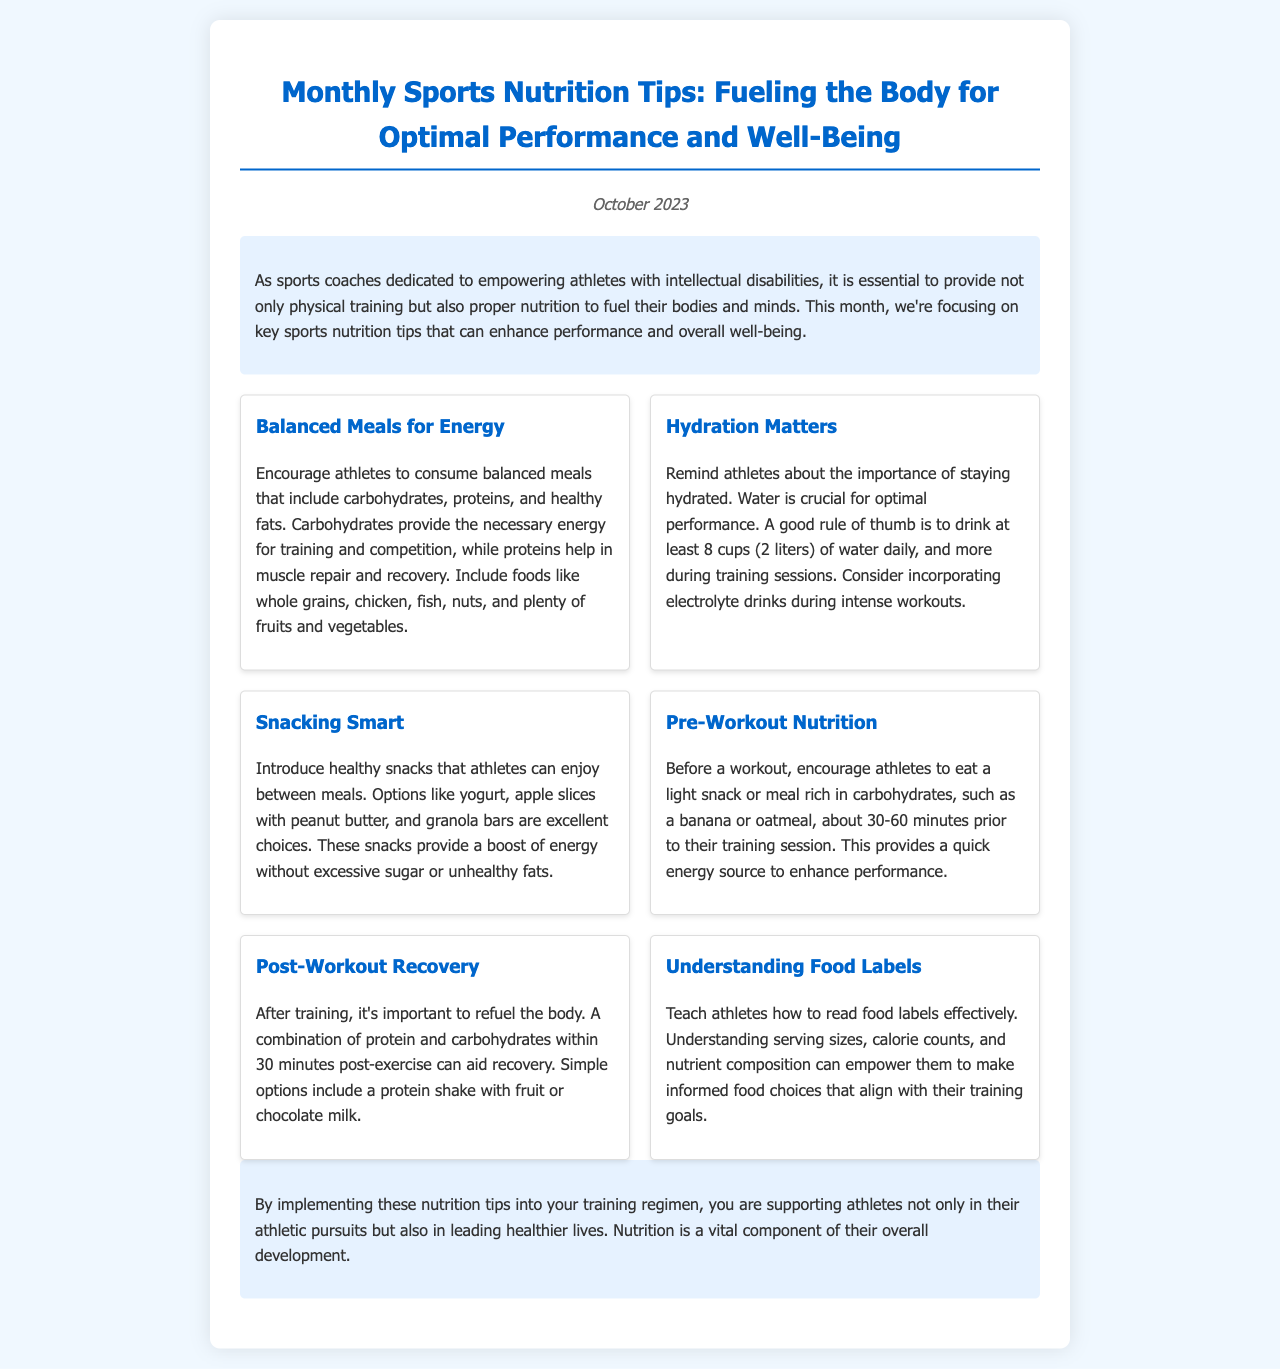What is the title of the newsletter? The title of the newsletter is prominently displayed at the top.
Answer: Monthly Sports Nutrition Tips: Fueling the Body for Optimal Performance and Well-Being What month is this newsletter for? The publication date indicates the specific month that the newsletter is covering.
Answer: October 2023 How many cups of water should athletes drink daily? The document provides a guideline for daily water intake under the hydration tip.
Answer: 8 cups What is recommended as a good pre-workout snack? The pre-workout nutrition section suggests specific food items for energy.
Answer: A banana or oatmeal What components are included in post-workout recovery nutrition? The post-workout recovery section describes the ideal combination of nutrients after exercise.
Answer: Protein and carbohydrates Which food types should be included in balanced meals? The balanced meals tip describes the types of food necessary for a nutritious meal.
Answer: Carbohydrates, proteins, and healthy fats Why is it important to understand food labels? The understanding food labels tip explains the benefit of this knowledge.
Answer: To make informed food choices What is a recommended healthy snack option? The snacking smart tip lists snacks that are beneficial for athletes.
Answer: Yogurt What role do carbohydrates play in an athlete's diet? The balanced meals section explains the importance of carbohydrates for athletes.
Answer: Provide energy 